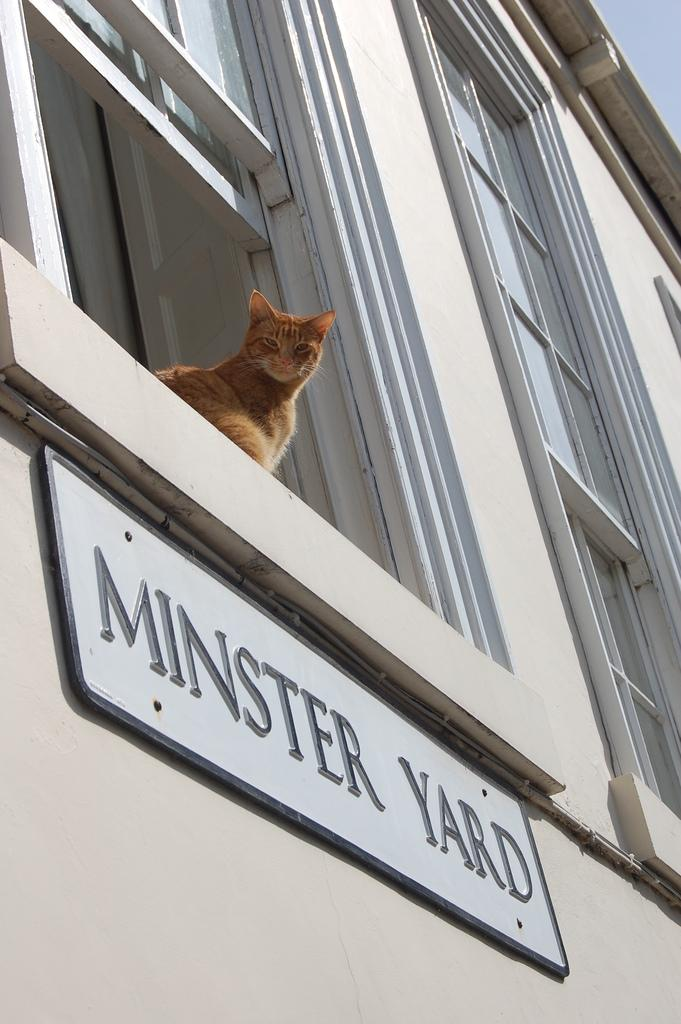What animal can be seen in the image? There is a cat sitting near the window in the image. What is attached to the wall in the image? There is a name board attached to the wall in the image. What type of architectural feature is present in the image? There are windows with doors in the image. What type of vessel is the cat using to sail in the image? There is no vessel present in the image, and the cat is not sailing. 